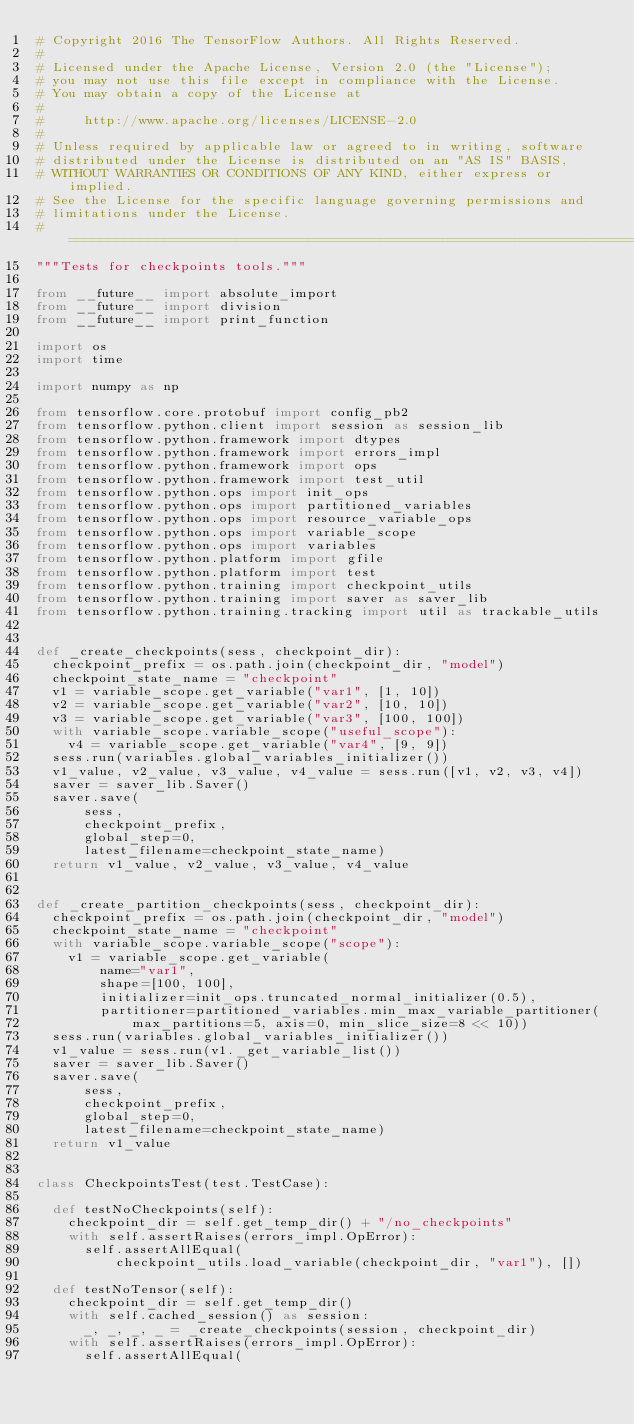Convert code to text. <code><loc_0><loc_0><loc_500><loc_500><_Python_># Copyright 2016 The TensorFlow Authors. All Rights Reserved.
#
# Licensed under the Apache License, Version 2.0 (the "License");
# you may not use this file except in compliance with the License.
# You may obtain a copy of the License at
#
#     http://www.apache.org/licenses/LICENSE-2.0
#
# Unless required by applicable law or agreed to in writing, software
# distributed under the License is distributed on an "AS IS" BASIS,
# WITHOUT WARRANTIES OR CONDITIONS OF ANY KIND, either express or implied.
# See the License for the specific language governing permissions and
# limitations under the License.
# ==============================================================================
"""Tests for checkpoints tools."""

from __future__ import absolute_import
from __future__ import division
from __future__ import print_function

import os
import time

import numpy as np

from tensorflow.core.protobuf import config_pb2
from tensorflow.python.client import session as session_lib
from tensorflow.python.framework import dtypes
from tensorflow.python.framework import errors_impl
from tensorflow.python.framework import ops
from tensorflow.python.framework import test_util
from tensorflow.python.ops import init_ops
from tensorflow.python.ops import partitioned_variables
from tensorflow.python.ops import resource_variable_ops
from tensorflow.python.ops import variable_scope
from tensorflow.python.ops import variables
from tensorflow.python.platform import gfile
from tensorflow.python.platform import test
from tensorflow.python.training import checkpoint_utils
from tensorflow.python.training import saver as saver_lib
from tensorflow.python.training.tracking import util as trackable_utils


def _create_checkpoints(sess, checkpoint_dir):
  checkpoint_prefix = os.path.join(checkpoint_dir, "model")
  checkpoint_state_name = "checkpoint"
  v1 = variable_scope.get_variable("var1", [1, 10])
  v2 = variable_scope.get_variable("var2", [10, 10])
  v3 = variable_scope.get_variable("var3", [100, 100])
  with variable_scope.variable_scope("useful_scope"):
    v4 = variable_scope.get_variable("var4", [9, 9])
  sess.run(variables.global_variables_initializer())
  v1_value, v2_value, v3_value, v4_value = sess.run([v1, v2, v3, v4])
  saver = saver_lib.Saver()
  saver.save(
      sess,
      checkpoint_prefix,
      global_step=0,
      latest_filename=checkpoint_state_name)
  return v1_value, v2_value, v3_value, v4_value


def _create_partition_checkpoints(sess, checkpoint_dir):
  checkpoint_prefix = os.path.join(checkpoint_dir, "model")
  checkpoint_state_name = "checkpoint"
  with variable_scope.variable_scope("scope"):
    v1 = variable_scope.get_variable(
        name="var1",
        shape=[100, 100],
        initializer=init_ops.truncated_normal_initializer(0.5),
        partitioner=partitioned_variables.min_max_variable_partitioner(
            max_partitions=5, axis=0, min_slice_size=8 << 10))
  sess.run(variables.global_variables_initializer())
  v1_value = sess.run(v1._get_variable_list())
  saver = saver_lib.Saver()
  saver.save(
      sess,
      checkpoint_prefix,
      global_step=0,
      latest_filename=checkpoint_state_name)
  return v1_value


class CheckpointsTest(test.TestCase):

  def testNoCheckpoints(self):
    checkpoint_dir = self.get_temp_dir() + "/no_checkpoints"
    with self.assertRaises(errors_impl.OpError):
      self.assertAllEqual(
          checkpoint_utils.load_variable(checkpoint_dir, "var1"), [])

  def testNoTensor(self):
    checkpoint_dir = self.get_temp_dir()
    with self.cached_session() as session:
      _, _, _, _ = _create_checkpoints(session, checkpoint_dir)
    with self.assertRaises(errors_impl.OpError):
      self.assertAllEqual(</code> 